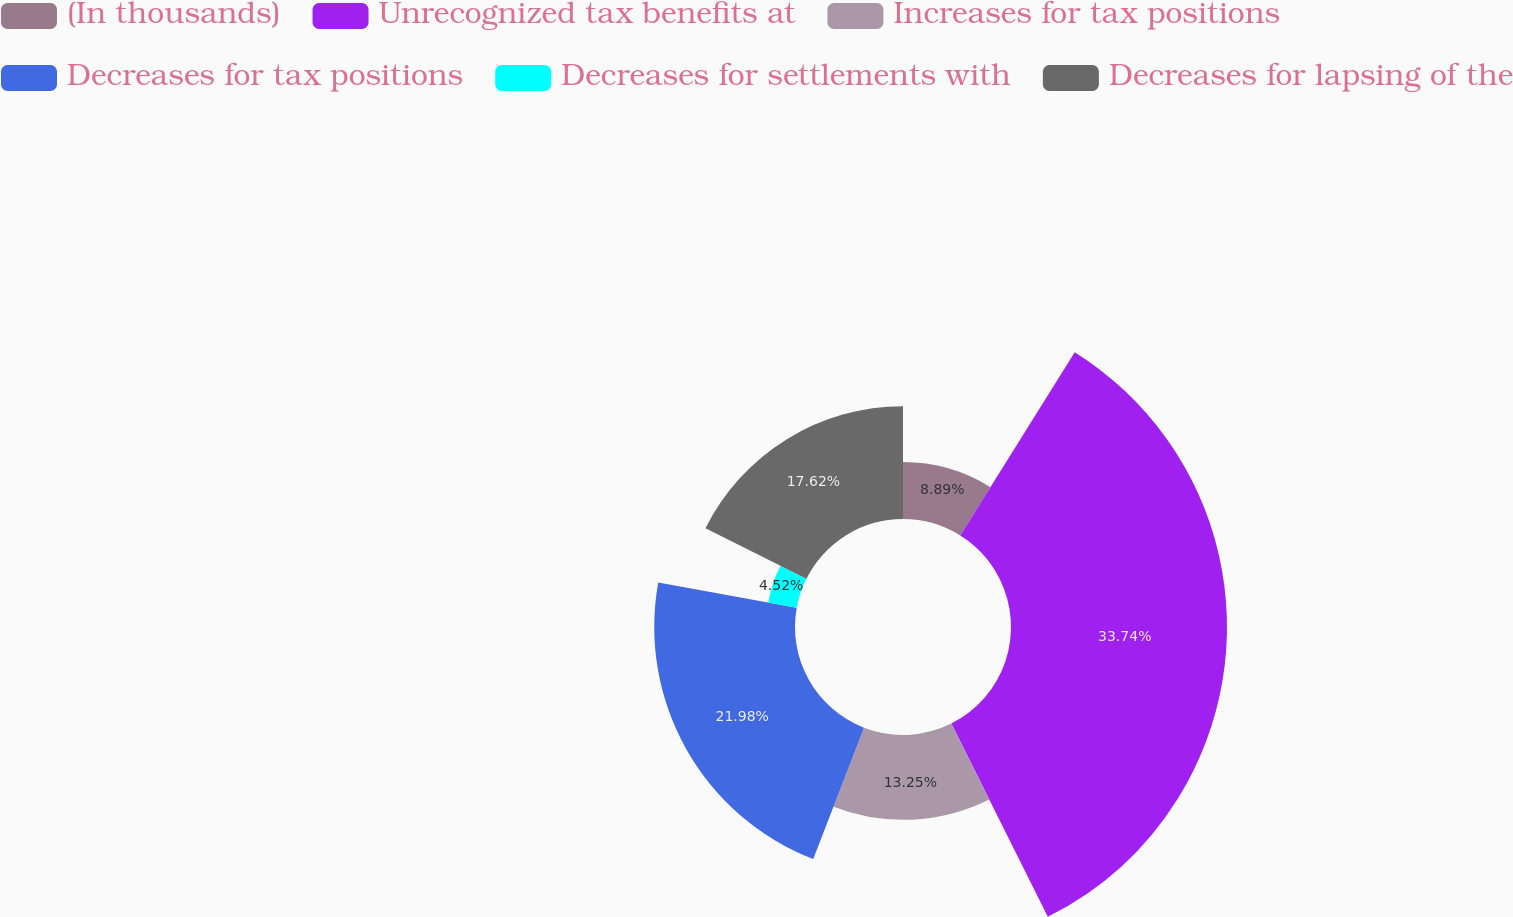<chart> <loc_0><loc_0><loc_500><loc_500><pie_chart><fcel>(In thousands)<fcel>Unrecognized tax benefits at<fcel>Increases for tax positions<fcel>Decreases for tax positions<fcel>Decreases for settlements with<fcel>Decreases for lapsing of the<nl><fcel>8.89%<fcel>33.73%<fcel>13.25%<fcel>21.98%<fcel>4.52%<fcel>17.62%<nl></chart> 